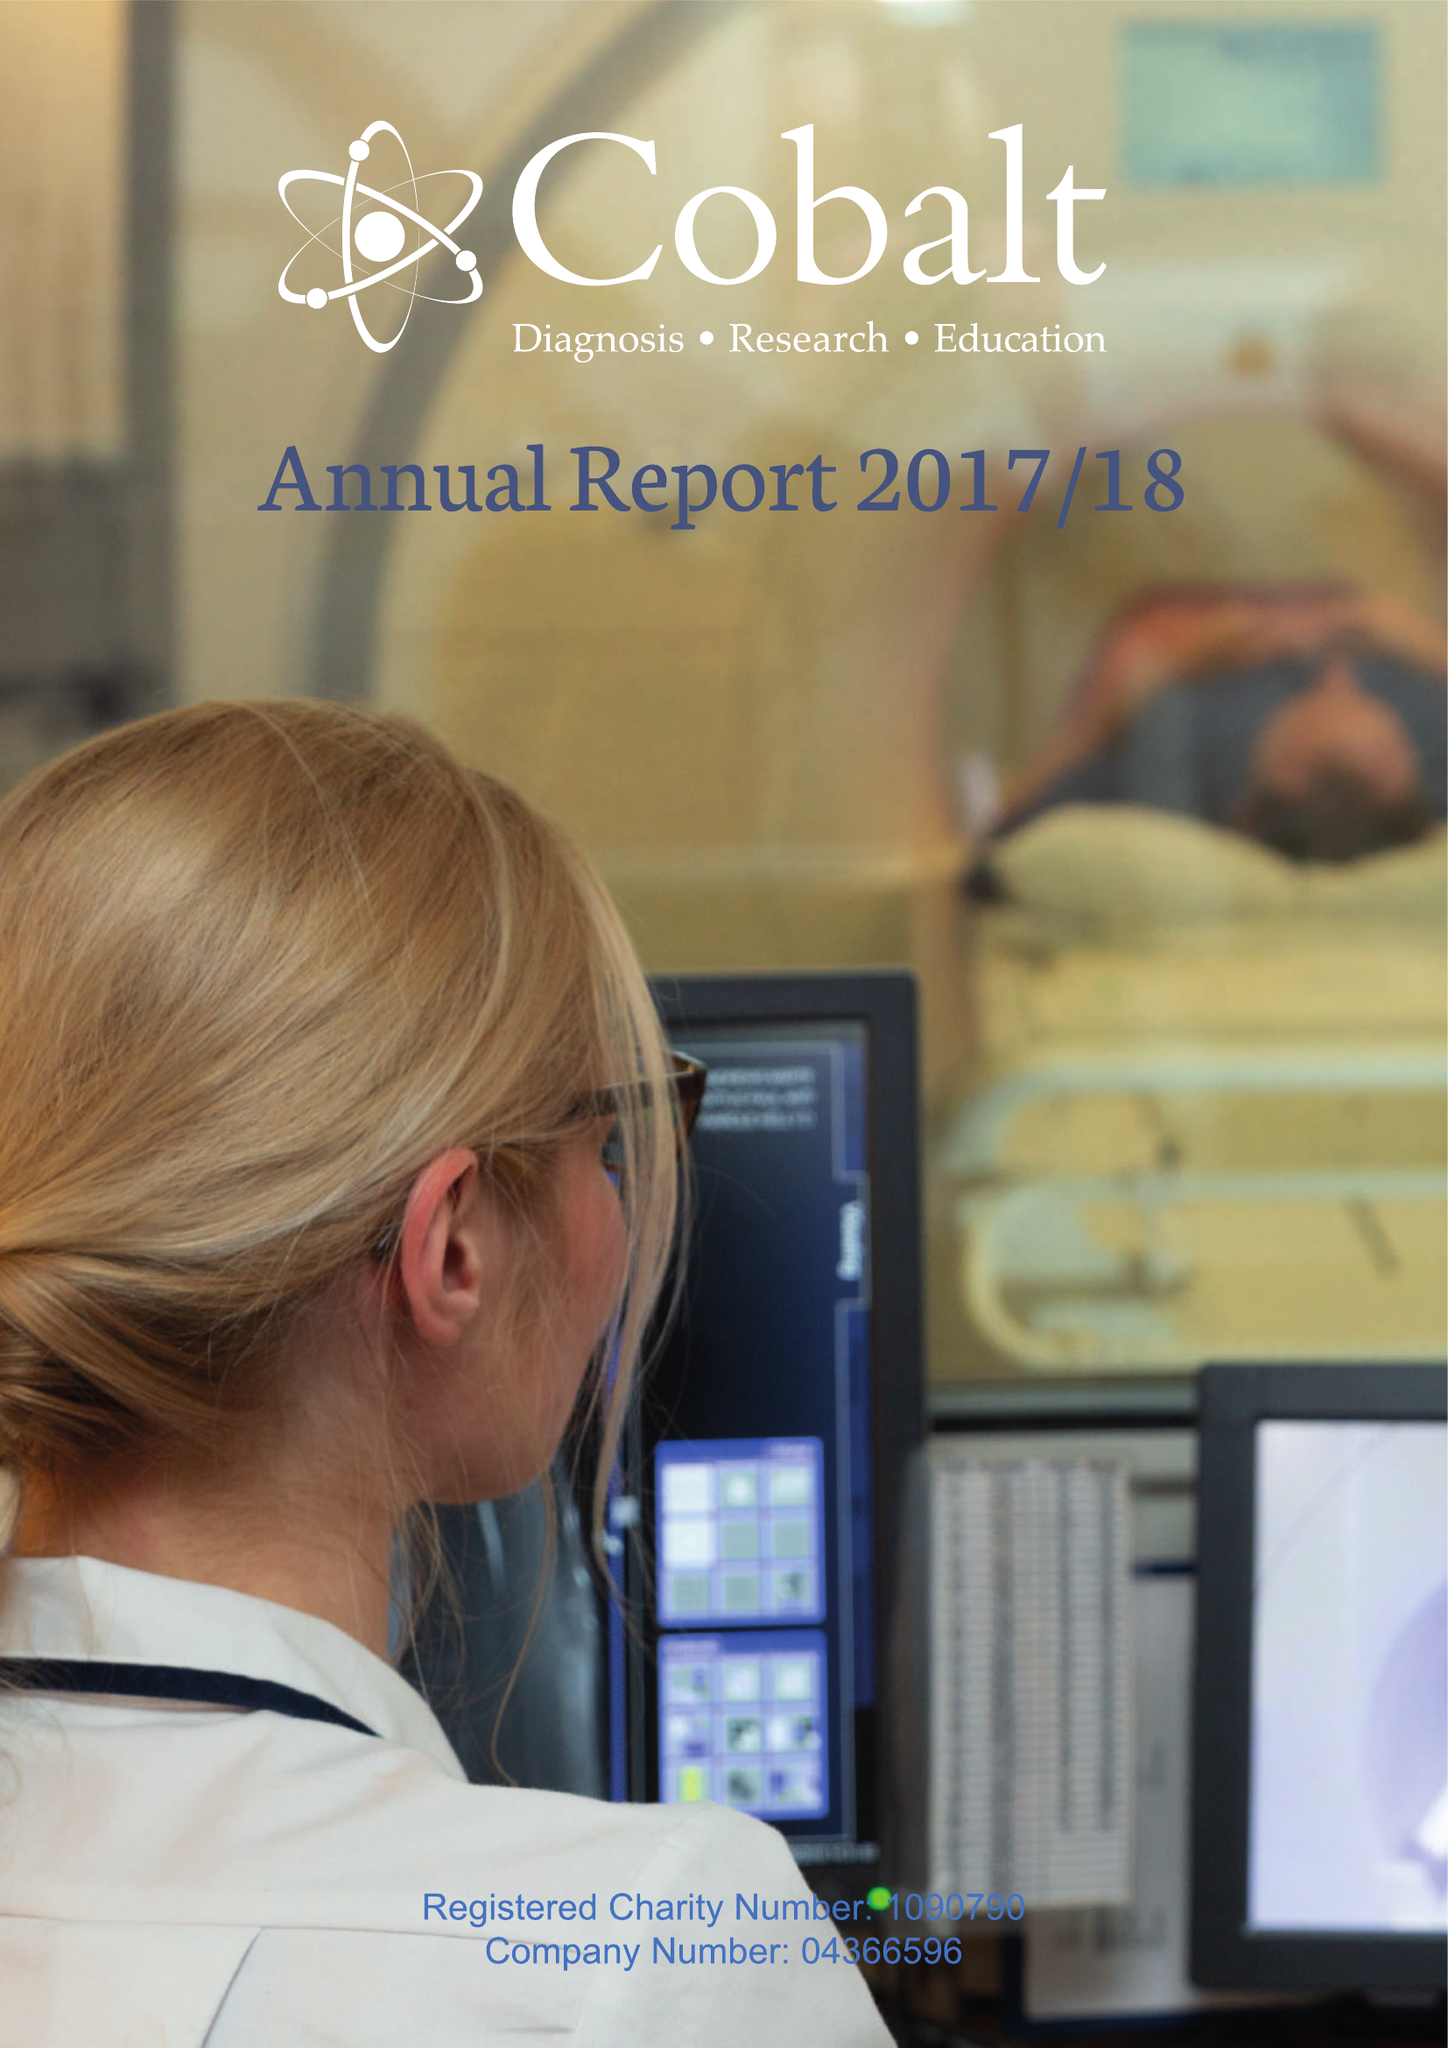What is the value for the spending_annually_in_british_pounds?
Answer the question using a single word or phrase. 9604929.00 